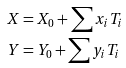<formula> <loc_0><loc_0><loc_500><loc_500>X & = X _ { 0 } + \sum x _ { i } T _ { i } \\ Y & = Y _ { 0 } + \sum y _ { i } T _ { i } \\</formula> 